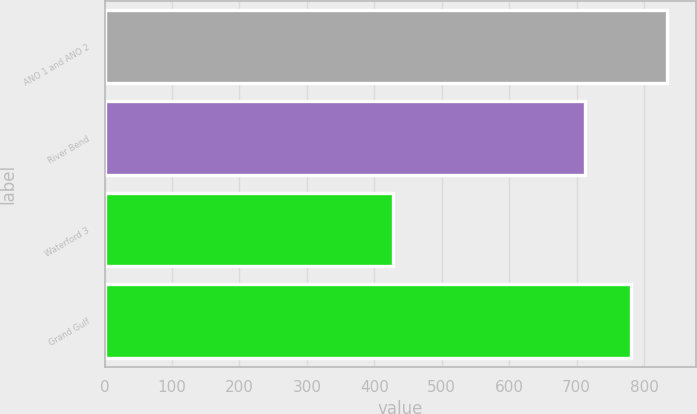Convert chart to OTSL. <chart><loc_0><loc_0><loc_500><loc_500><bar_chart><fcel>ANO 1 and ANO 2<fcel>River Bend<fcel>Waterford 3<fcel>Grand Gulf<nl><fcel>834.7<fcel>712.8<fcel>427.9<fcel>780.5<nl></chart> 